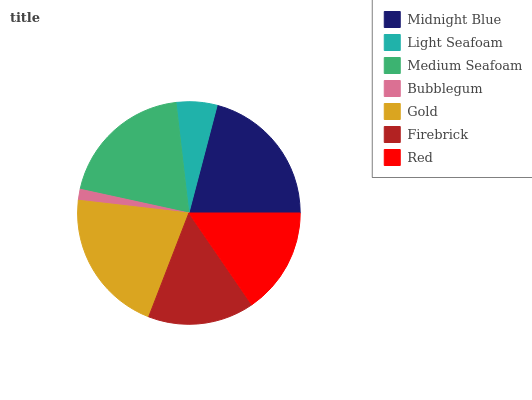Is Bubblegum the minimum?
Answer yes or no. Yes. Is Gold the maximum?
Answer yes or no. Yes. Is Light Seafoam the minimum?
Answer yes or no. No. Is Light Seafoam the maximum?
Answer yes or no. No. Is Midnight Blue greater than Light Seafoam?
Answer yes or no. Yes. Is Light Seafoam less than Midnight Blue?
Answer yes or no. Yes. Is Light Seafoam greater than Midnight Blue?
Answer yes or no. No. Is Midnight Blue less than Light Seafoam?
Answer yes or no. No. Is Red the high median?
Answer yes or no. Yes. Is Red the low median?
Answer yes or no. Yes. Is Midnight Blue the high median?
Answer yes or no. No. Is Midnight Blue the low median?
Answer yes or no. No. 